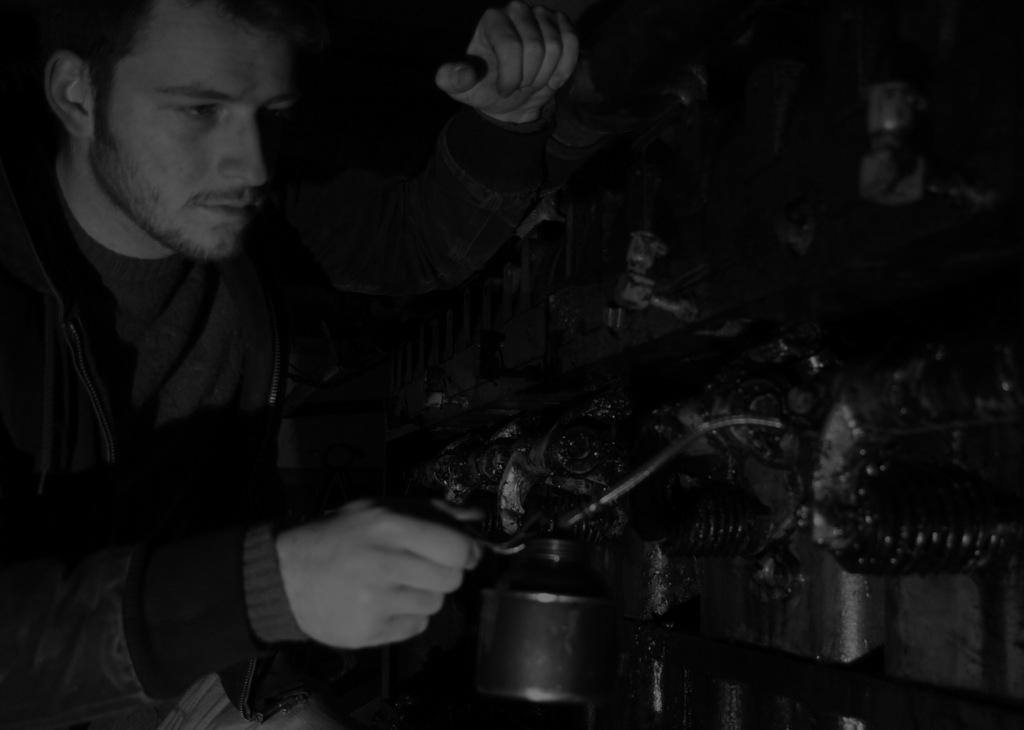How would you summarize this image in a sentence or two? It is a black and white image, there is a man and he is holding some object in his hand and in front of the man there is some machinery. 